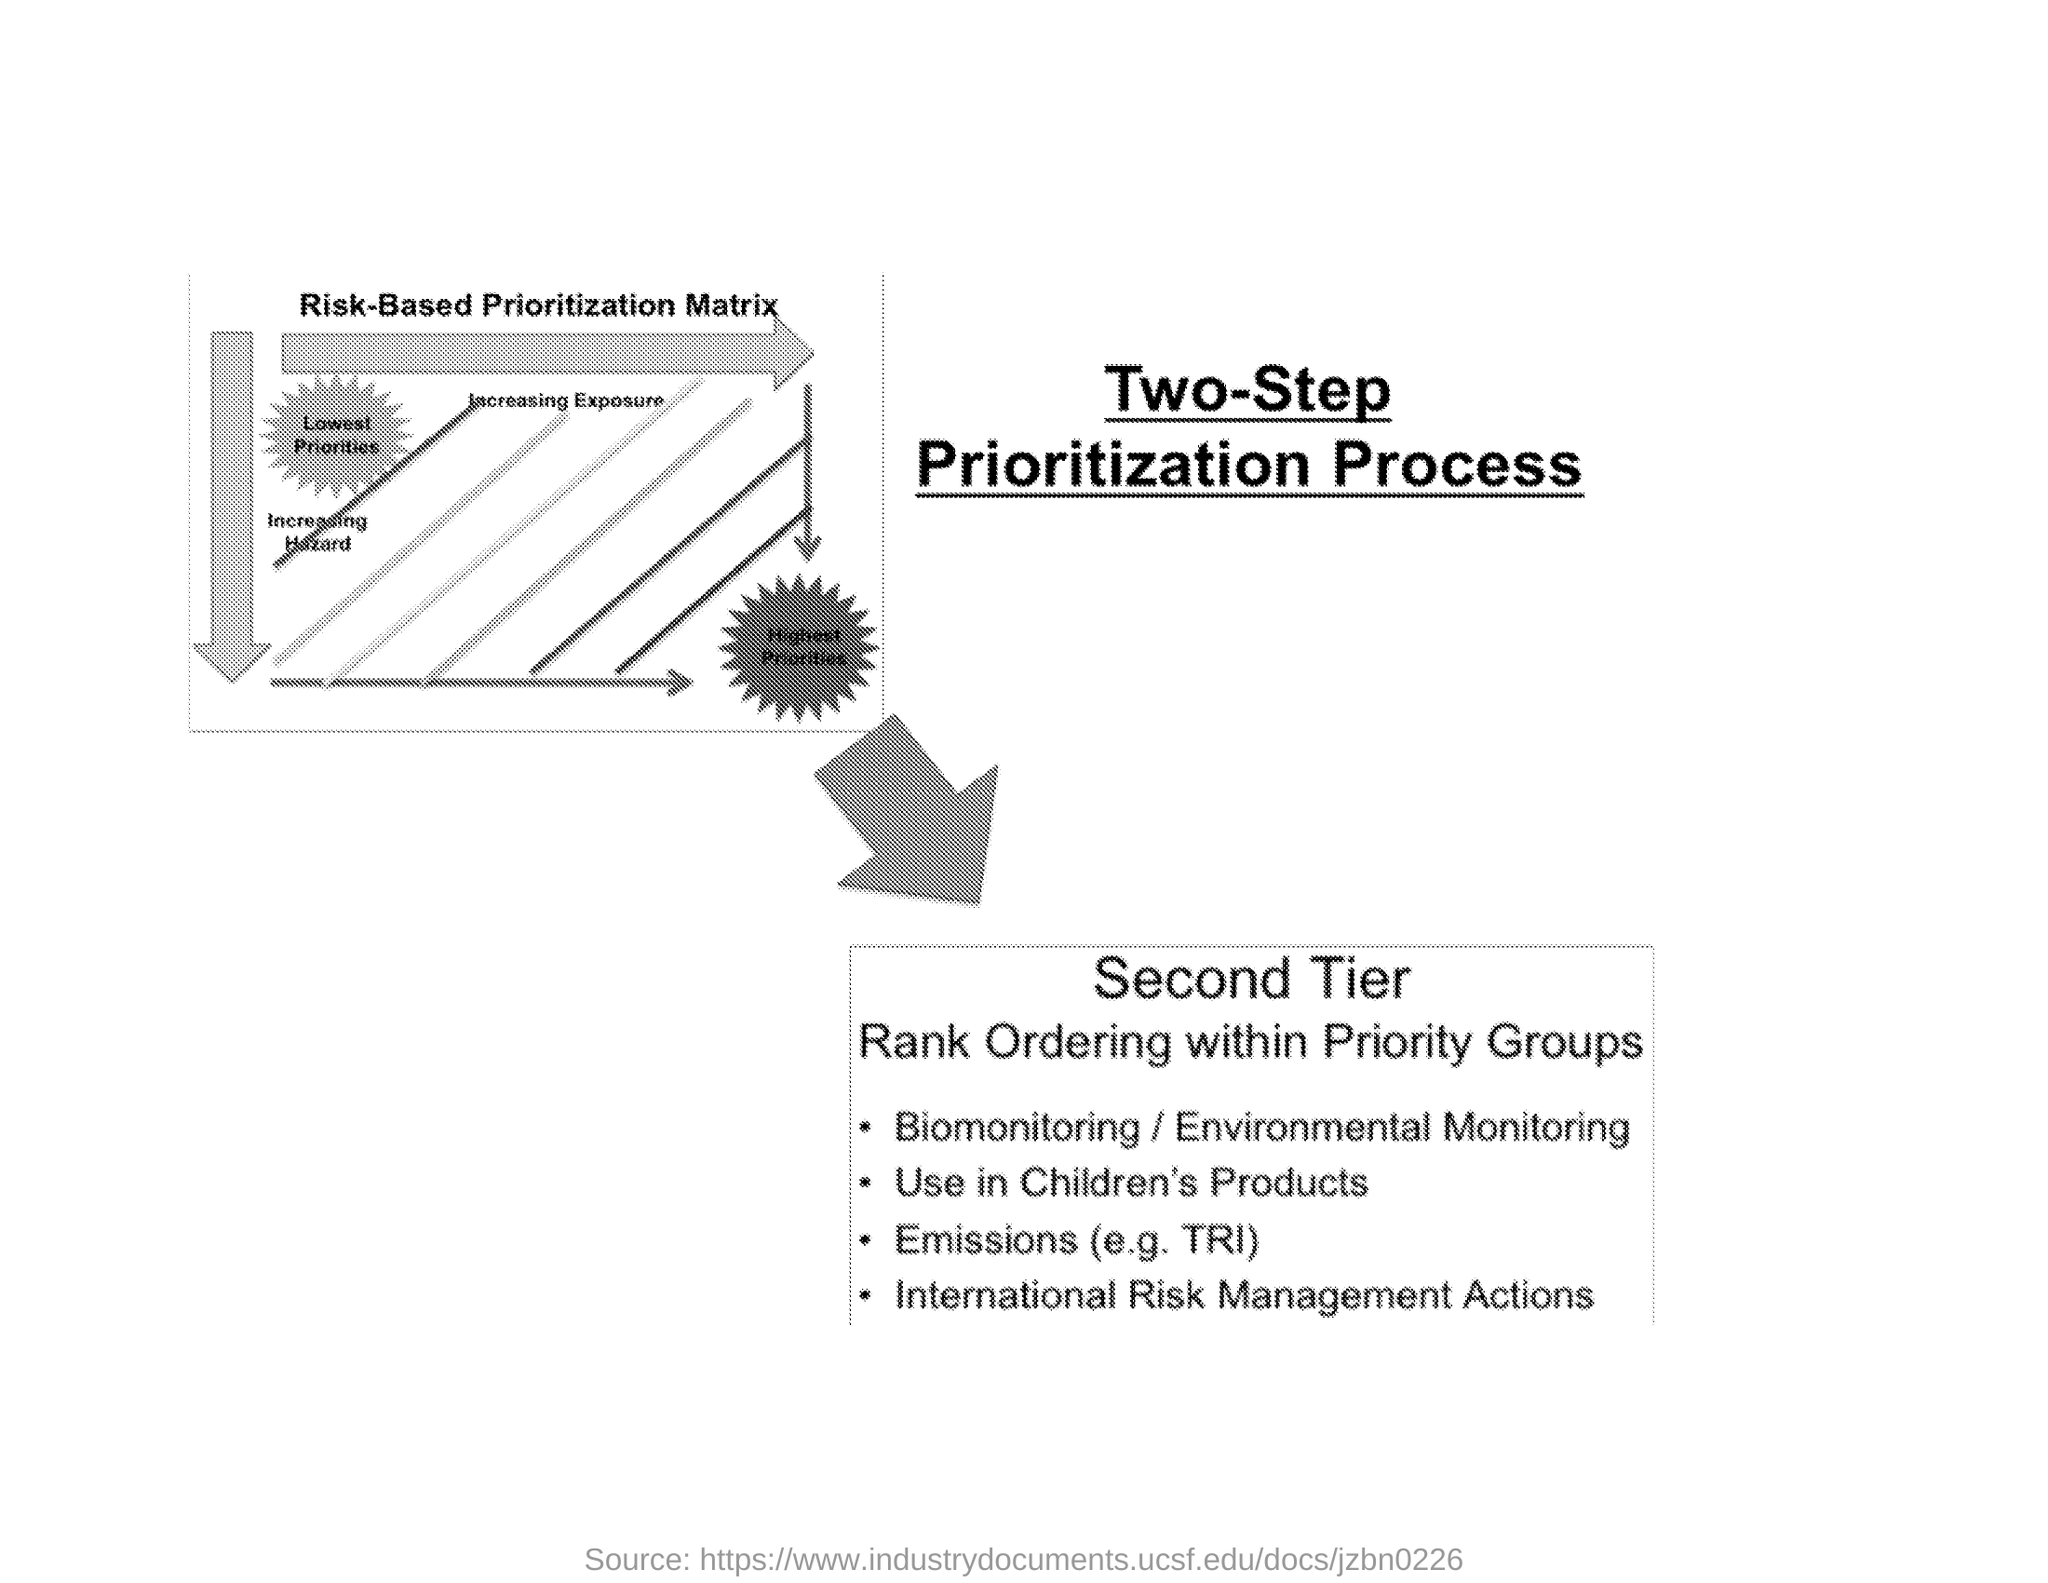Point out several critical features in this image. The prioritization process is a two-step process that involves determining the number of steps required for completion. Biomonitoring is often used as an alternative to environmental monitoring in order to assess the levels of pollutants and other substances in the environment. In the Second Tier, the ranking ordering is as follows: within which groups, priority is given based on the following criteria. The heading of the picture shown is 'Risk-Based Prioritization Matrix'. 